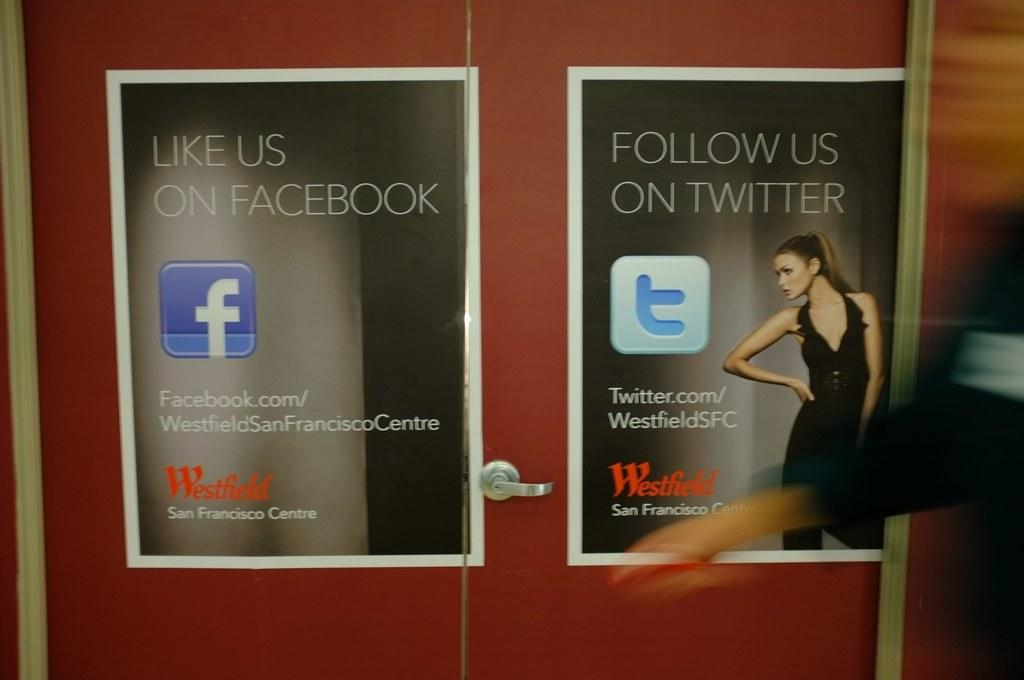What is the main object in the center of the image? There is a cupboard in the center of the image. What is on the cupboard? There are posters on the cupboard. How many beds can be seen in the image? There are no beds present in the image. Is there a fire burning in the image? There is no fire present in the image. 